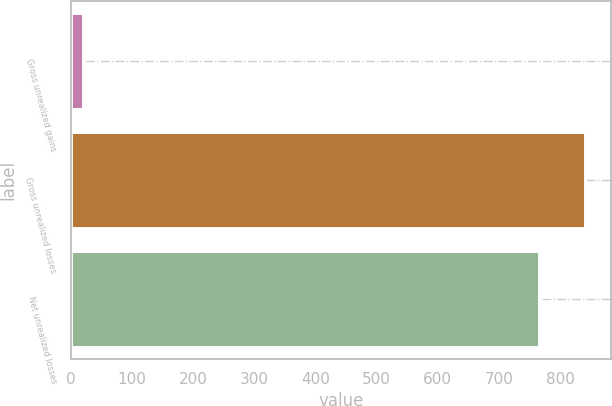<chart> <loc_0><loc_0><loc_500><loc_500><bar_chart><fcel>Gross unrealized gains<fcel>Gross unrealized losses<fcel>Net unrealized losses<nl><fcel>20<fcel>841.5<fcel>765<nl></chart> 